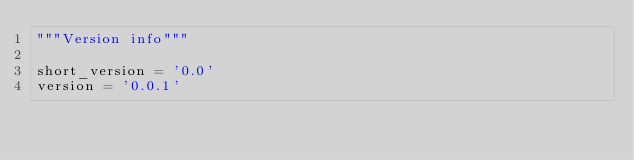Convert code to text. <code><loc_0><loc_0><loc_500><loc_500><_Python_>"""Version info"""

short_version = '0.0'
version = '0.0.1'
</code> 